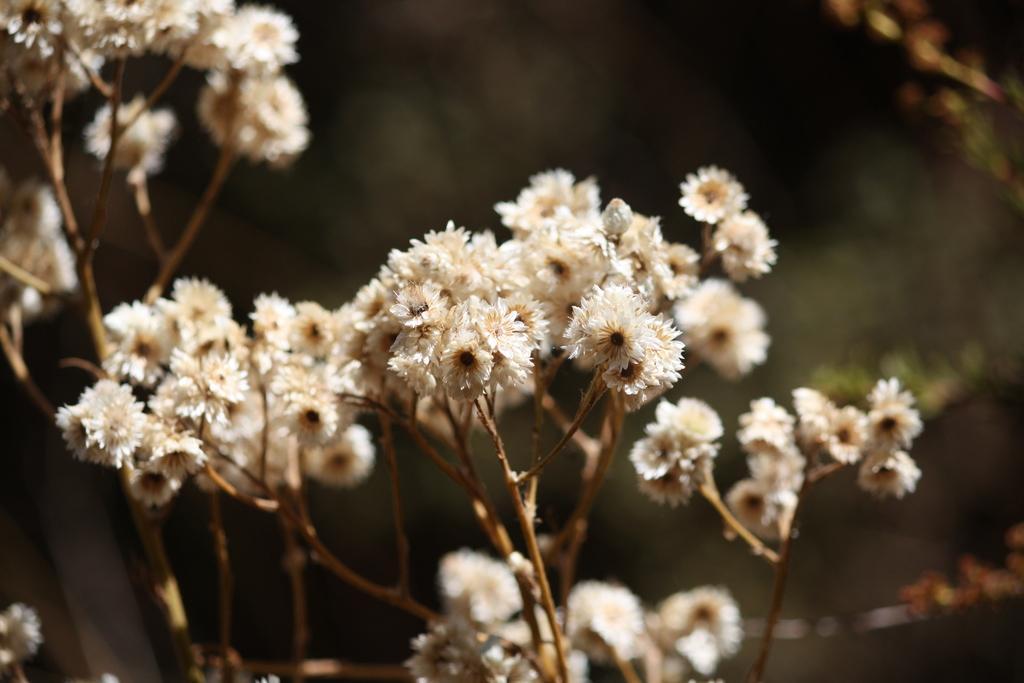Describe this image in one or two sentences. In this image I can see few flowers in white color and the background is in black and green color. 